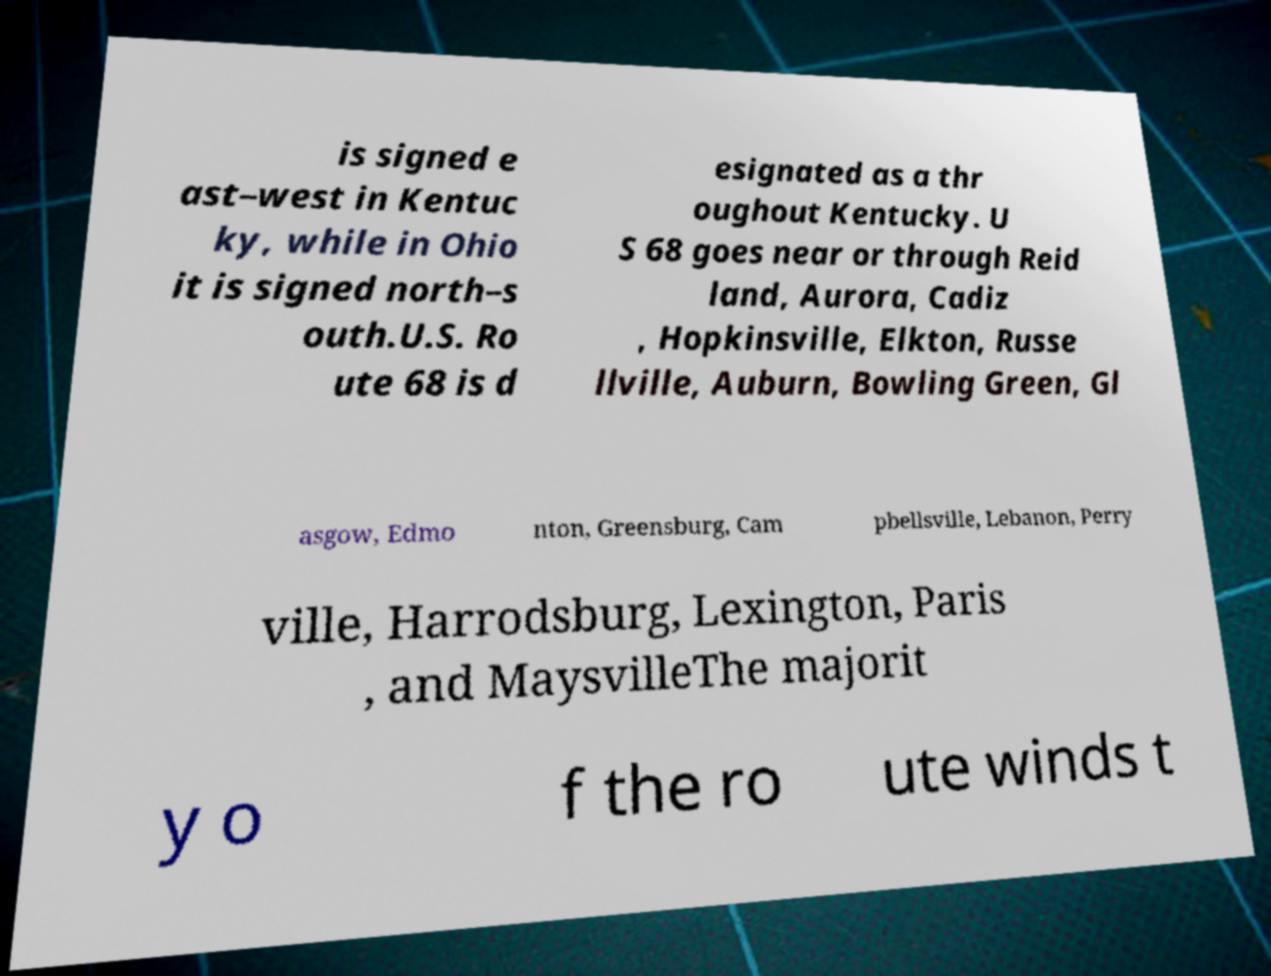Can you accurately transcribe the text from the provided image for me? is signed e ast–west in Kentuc ky, while in Ohio it is signed north–s outh.U.S. Ro ute 68 is d esignated as a thr oughout Kentucky. U S 68 goes near or through Reid land, Aurora, Cadiz , Hopkinsville, Elkton, Russe llville, Auburn, Bowling Green, Gl asgow, Edmo nton, Greensburg, Cam pbellsville, Lebanon, Perry ville, Harrodsburg, Lexington, Paris , and MaysvilleThe majorit y o f the ro ute winds t 